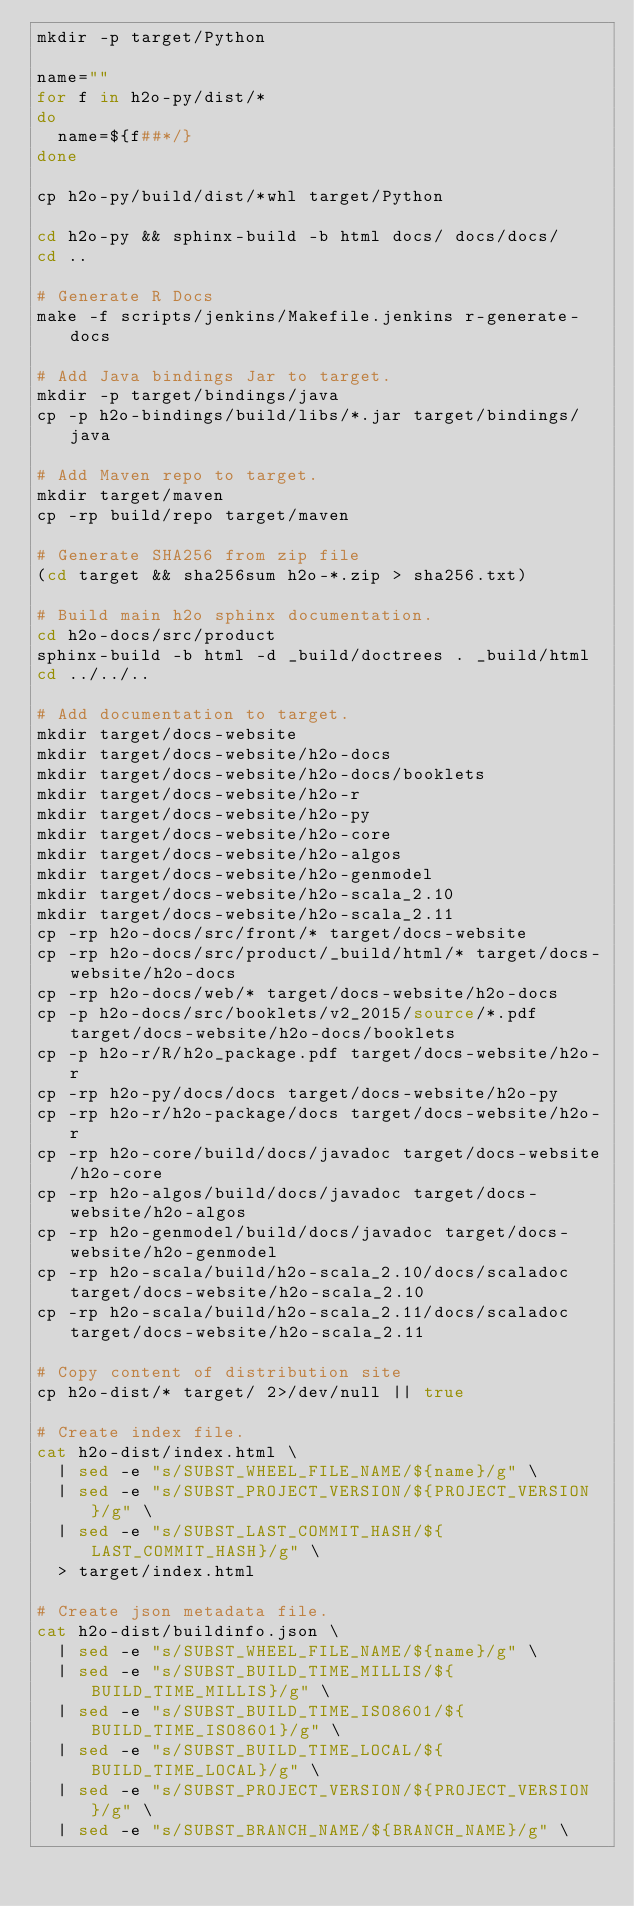Convert code to text. <code><loc_0><loc_0><loc_500><loc_500><_Bash_>mkdir -p target/Python

name=""
for f in h2o-py/dist/*
do
  name=${f##*/}
done

cp h2o-py/build/dist/*whl target/Python

cd h2o-py && sphinx-build -b html docs/ docs/docs/
cd ..

# Generate R Docs
make -f scripts/jenkins/Makefile.jenkins r-generate-docs

# Add Java bindings Jar to target.
mkdir -p target/bindings/java
cp -p h2o-bindings/build/libs/*.jar target/bindings/java

# Add Maven repo to target.
mkdir target/maven
cp -rp build/repo target/maven

# Generate SHA256 from zip file
(cd target && sha256sum h2o-*.zip > sha256.txt)

# Build main h2o sphinx documentation.
cd h2o-docs/src/product
sphinx-build -b html -d _build/doctrees . _build/html
cd ../../..

# Add documentation to target.
mkdir target/docs-website
mkdir target/docs-website/h2o-docs
mkdir target/docs-website/h2o-docs/booklets
mkdir target/docs-website/h2o-r
mkdir target/docs-website/h2o-py
mkdir target/docs-website/h2o-core
mkdir target/docs-website/h2o-algos
mkdir target/docs-website/h2o-genmodel
mkdir target/docs-website/h2o-scala_2.10
mkdir target/docs-website/h2o-scala_2.11
cp -rp h2o-docs/src/front/* target/docs-website
cp -rp h2o-docs/src/product/_build/html/* target/docs-website/h2o-docs
cp -rp h2o-docs/web/* target/docs-website/h2o-docs
cp -p h2o-docs/src/booklets/v2_2015/source/*.pdf target/docs-website/h2o-docs/booklets
cp -p h2o-r/R/h2o_package.pdf target/docs-website/h2o-r
cp -rp h2o-py/docs/docs target/docs-website/h2o-py
cp -rp h2o-r/h2o-package/docs target/docs-website/h2o-r
cp -rp h2o-core/build/docs/javadoc target/docs-website/h2o-core
cp -rp h2o-algos/build/docs/javadoc target/docs-website/h2o-algos
cp -rp h2o-genmodel/build/docs/javadoc target/docs-website/h2o-genmodel
cp -rp h2o-scala/build/h2o-scala_2.10/docs/scaladoc target/docs-website/h2o-scala_2.10
cp -rp h2o-scala/build/h2o-scala_2.11/docs/scaladoc target/docs-website/h2o-scala_2.11

# Copy content of distribution site
cp h2o-dist/* target/ 2>/dev/null || true

# Create index file.
cat h2o-dist/index.html \
  | sed -e "s/SUBST_WHEEL_FILE_NAME/${name}/g" \
  | sed -e "s/SUBST_PROJECT_VERSION/${PROJECT_VERSION}/g" \
  | sed -e "s/SUBST_LAST_COMMIT_HASH/${LAST_COMMIT_HASH}/g" \
  > target/index.html

# Create json metadata file.
cat h2o-dist/buildinfo.json \
  | sed -e "s/SUBST_WHEEL_FILE_NAME/${name}/g" \
  | sed -e "s/SUBST_BUILD_TIME_MILLIS/${BUILD_TIME_MILLIS}/g" \
  | sed -e "s/SUBST_BUILD_TIME_ISO8601/${BUILD_TIME_ISO8601}/g" \
  | sed -e "s/SUBST_BUILD_TIME_LOCAL/${BUILD_TIME_LOCAL}/g" \
  | sed -e "s/SUBST_PROJECT_VERSION/${PROJECT_VERSION}/g" \
  | sed -e "s/SUBST_BRANCH_NAME/${BRANCH_NAME}/g" \</code> 